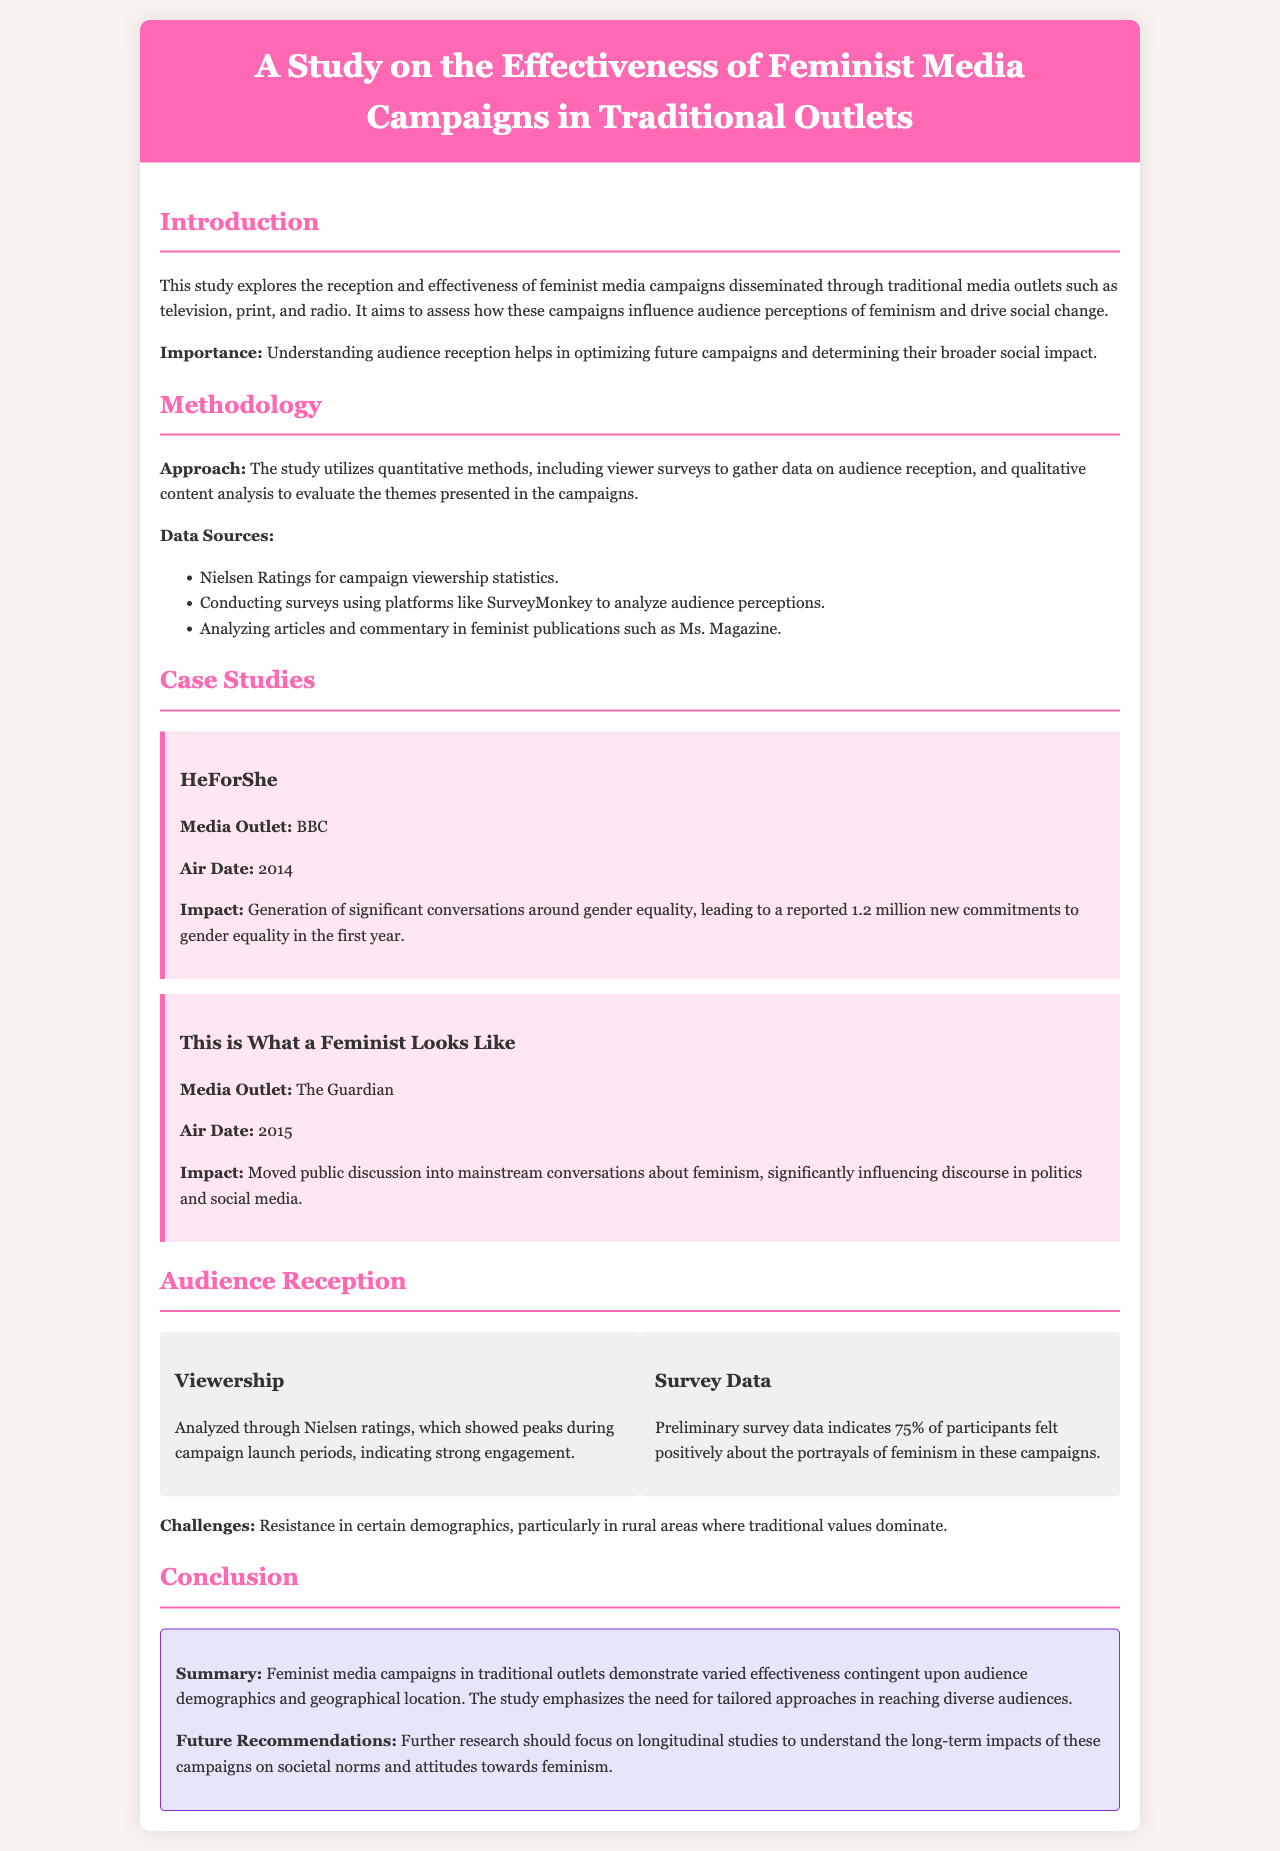what is the main aim of the study? The aim of the study is to assess how feminist media campaigns influence audience perceptions of feminism and drive social change.
Answer: to assess audience perceptions of feminism and drive social change which media outlet aired the HeForShe campaign? The HeForShe campaign was aired by the BBC.
Answer: BBC what percentage of survey participants felt positively about portrayals of feminism? Preliminary survey data indicates that 75% of participants felt positively about the portrayals of feminism.
Answer: 75% in what year did the campaign "This is What a Feminist Looks Like" air? The campaign aired in 2015.
Answer: 2015 what is one challenge mentioned regarding audience reception? The study mentions resistance in certain demographics, particularly in rural areas.
Answer: resistance in rural areas what method was used to gather audience reception data? The study utilized viewer surveys to gather data on audience reception.
Answer: viewer surveys what is the suggested focus for future research? The study recommends focusing on longitudinal studies to understand the long-term impacts of these campaigns.
Answer: longitudinal studies what impact did the HeForShe campaign reportedly generate in its first year? It led to a reported 1.2 million new commitments to gender equality in the first year.
Answer: 1.2 million new commitments what is the documented effectiveness of feminist media campaigns dependent on? The effectiveness is contingent upon audience demographics and geographical location.
Answer: audience demographics and geographical location 